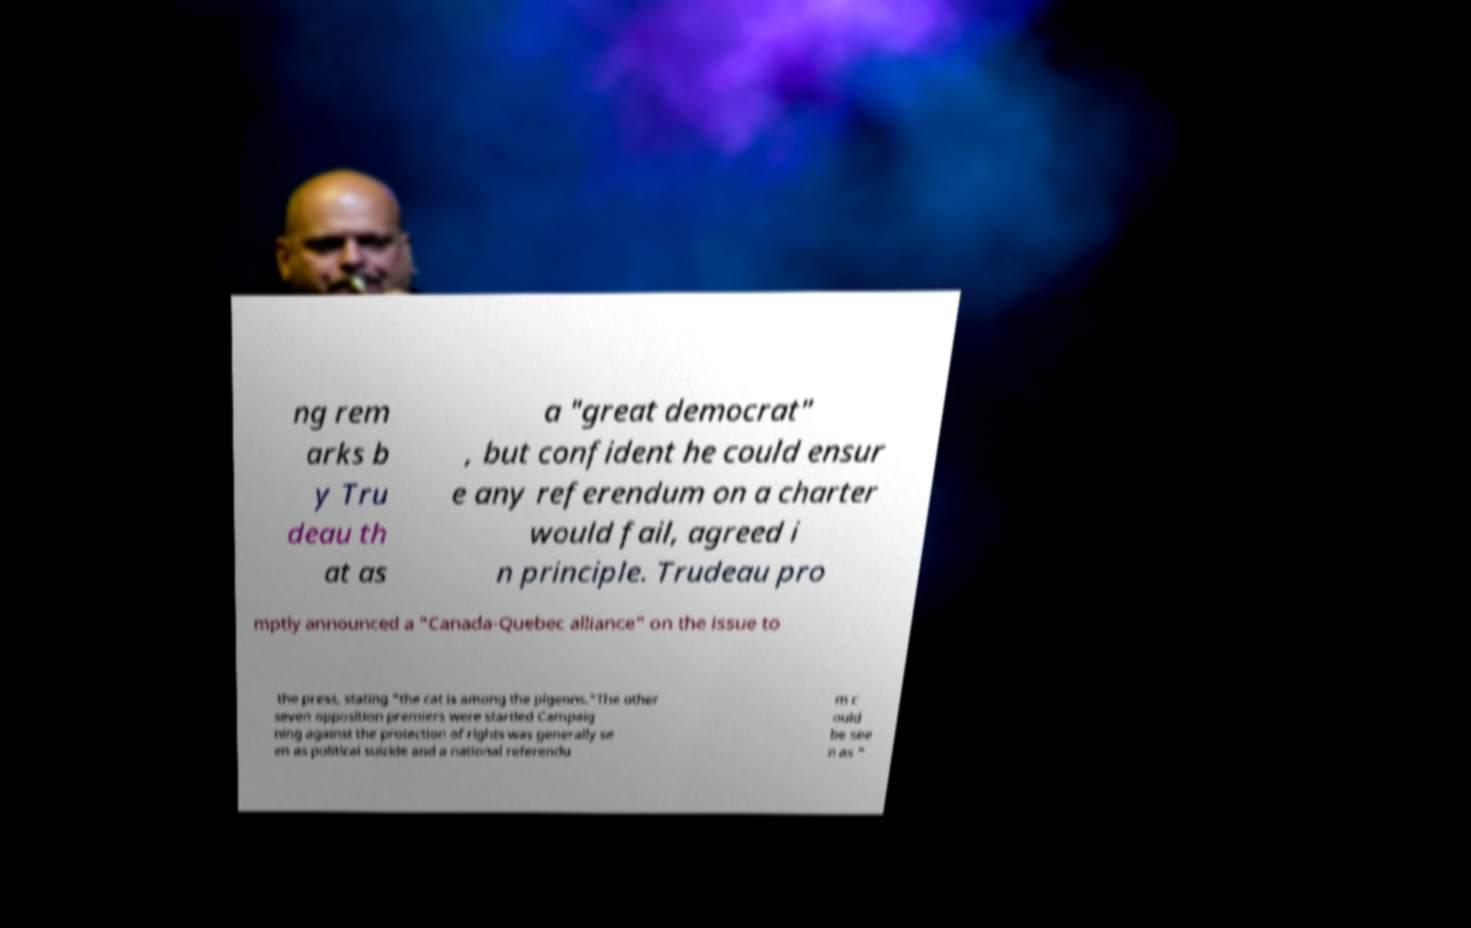For documentation purposes, I need the text within this image transcribed. Could you provide that? ng rem arks b y Tru deau th at as a "great democrat" , but confident he could ensur e any referendum on a charter would fail, agreed i n principle. Trudeau pro mptly announced a "Canada-Quebec alliance" on the issue to the press, stating "the cat is among the pigeons."The other seven opposition premiers were startled Campaig ning against the protection of rights was generally se en as political suicide and a national referendu m c ould be see n as " 